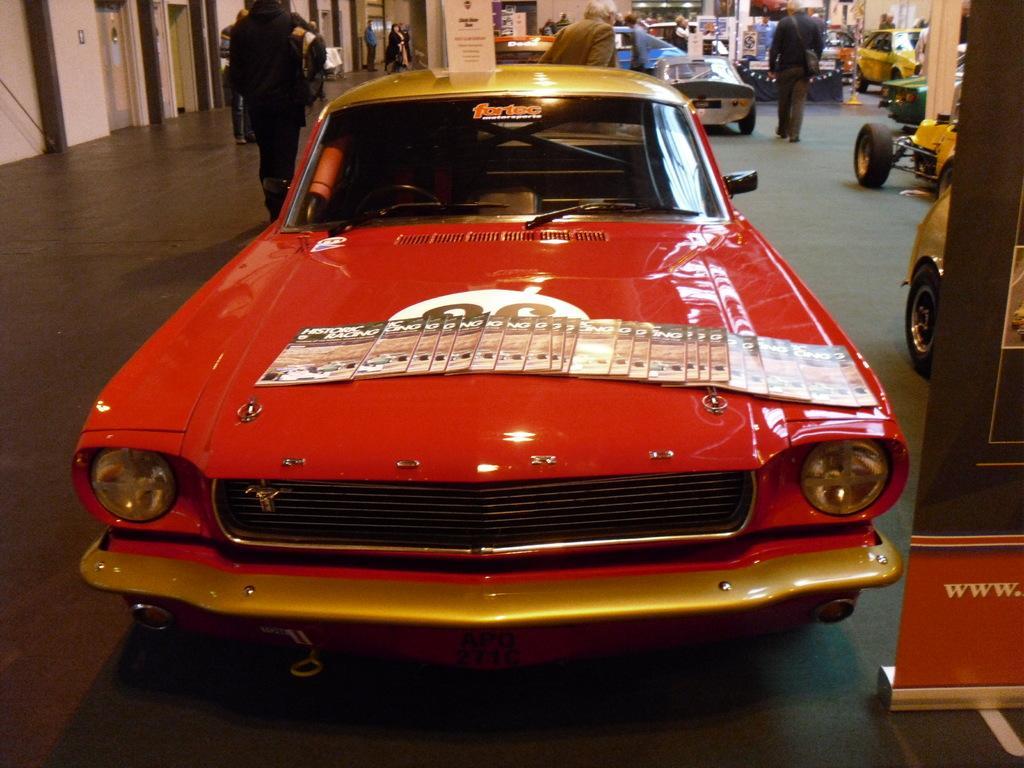Could you give a brief overview of what you see in this image? In this image, I can see different types of cars. These are the books, which are placed on the car. This looks like a banner. I can see few people walking. These are the doors. I think this is the car showroom. 